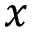Convert formula to latex. <formula><loc_0><loc_0><loc_500><loc_500>x</formula> 